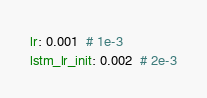<code> <loc_0><loc_0><loc_500><loc_500><_YAML_>lr: 0.001  # 1e-3
lstm_lr_init: 0.002  # 2e-3</code> 